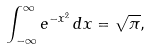Convert formula to latex. <formula><loc_0><loc_0><loc_500><loc_500>\int _ { - \infty } ^ { \infty } e ^ { - x ^ { 2 } } \, d x = \sqrt { \pi } ,</formula> 